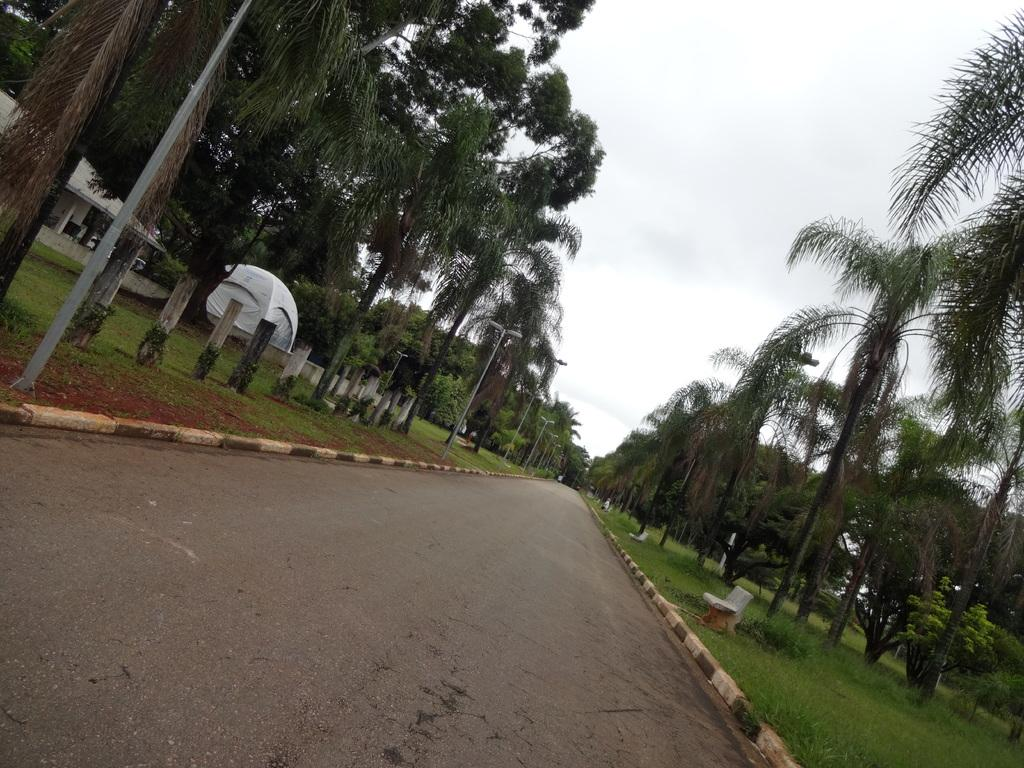What type of pathway is visible in the image? There is a road in the image. What type of seating is present in the image? There is a bench in the image. What structures provide illumination in the image? There are light poles in the image. What type of poles can be seen in the image? There are wooden poles in the image. What type of vegetation is present in the image? There are trees and grass in the image. What type of architectural elements can be seen in the image? There are pillars in the image. What type of temporary shelter is present in the image? There is a tent in the image. What is visible in the background of the image? The sky is visible in the background of the image. Can you tell me how many vases are placed on the bench in the image? There are no vases present on the bench or anywhere else in the image. How does the tent stop the wind from blowing in the image? The tent does not stop the wind from blowing in the image; it is a temporary shelter and not a wind barrier. 